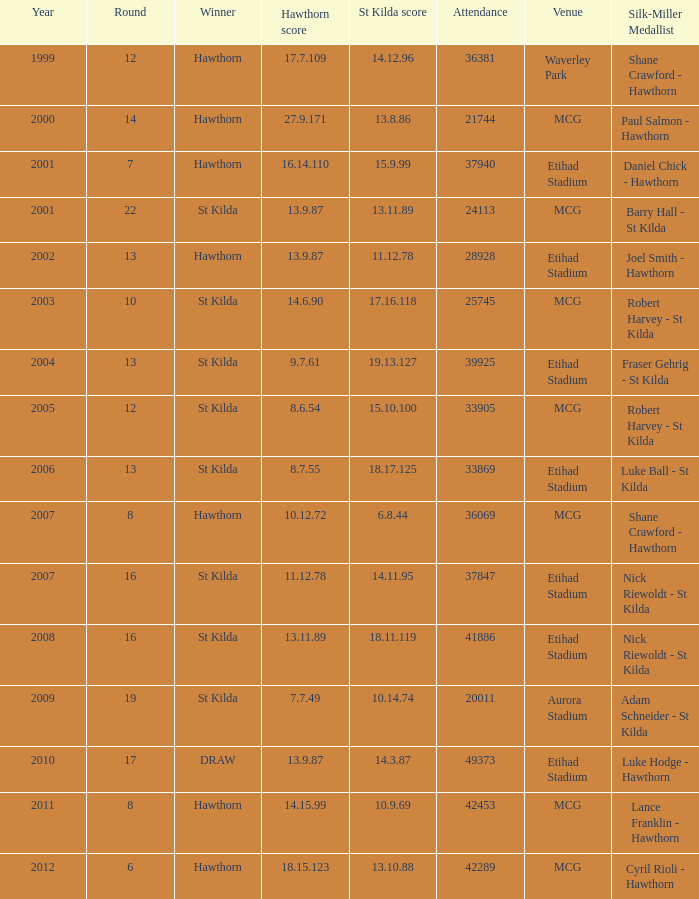1 42289.0. 